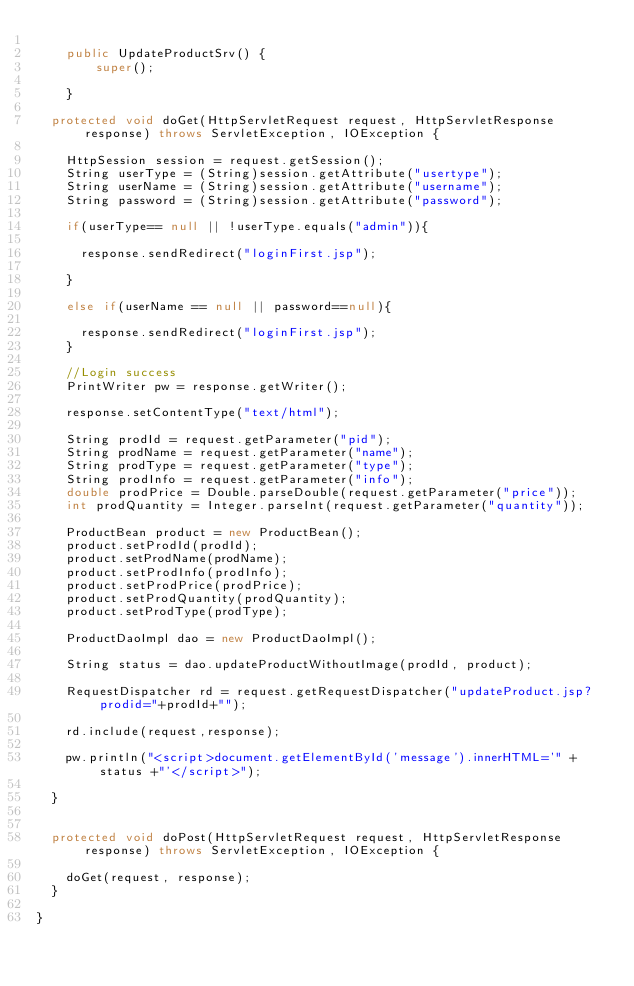Convert code to text. <code><loc_0><loc_0><loc_500><loc_500><_Java_>      
    public UpdateProductSrv() {
        super();

    }

	protected void doGet(HttpServletRequest request, HttpServletResponse response) throws ServletException, IOException {

		HttpSession session = request.getSession();
		String userType = (String)session.getAttribute("usertype");
		String userName = (String)session.getAttribute("username");
		String password = (String)session.getAttribute("password");
	
		if(userType== null || !userType.equals("admin")){
			
			response.sendRedirect("loginFirst.jsp");
			
		}
		
		else if(userName == null || password==null){
	
			response.sendRedirect("loginFirst.jsp");
		}	
		
		//Login success
		PrintWriter pw = response.getWriter();
		
		response.setContentType("text/html");
		
		String prodId = request.getParameter("pid");
		String prodName = request.getParameter("name");
		String prodType = request.getParameter("type");
		String prodInfo = request.getParameter("info");
		double prodPrice = Double.parseDouble(request.getParameter("price"));
		int prodQuantity = Integer.parseInt(request.getParameter("quantity"));
		
		ProductBean product = new ProductBean();
		product.setProdId(prodId);
		product.setProdName(prodName);
		product.setProdInfo(prodInfo);
		product.setProdPrice(prodPrice);
		product.setProdQuantity(prodQuantity);
		product.setProdType(prodType);
		
		ProductDaoImpl dao = new ProductDaoImpl();
		
		String status = dao.updateProductWithoutImage(prodId, product);
		
		RequestDispatcher rd = request.getRequestDispatcher("updateProduct.jsp?prodid="+prodId+"");
		
		rd.include(request,response);
		
		pw.println("<script>document.getElementById('message').innerHTML='" + status +"'</script>");
	
	}

	
	protected void doPost(HttpServletRequest request, HttpServletResponse response) throws ServletException, IOException {
		
		doGet(request, response);
	}

}
</code> 